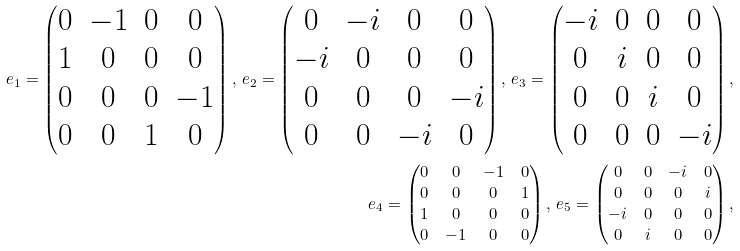<formula> <loc_0><loc_0><loc_500><loc_500>e _ { 1 } = \begin{pmatrix} 0 & - 1 & 0 & 0 \\ 1 & 0 & 0 & 0 \\ 0 & 0 & 0 & - 1 \\ 0 & 0 & 1 & 0 \end{pmatrix} , \, e _ { 2 } = \begin{pmatrix} 0 & - i & 0 & 0 \\ - i & 0 & 0 & 0 \\ 0 & 0 & 0 & - i \\ 0 & 0 & - i & 0 \end{pmatrix} , \, e _ { 3 } = \begin{pmatrix} - i & 0 & 0 & 0 \\ 0 & i & 0 & 0 \\ 0 & 0 & i & 0 \\ 0 & 0 & 0 & - i \end{pmatrix} , \\ e _ { 4 } = \begin{pmatrix} 0 & 0 & - 1 & 0 \\ 0 & 0 & 0 & 1 \\ 1 & 0 & 0 & 0 \\ 0 & - 1 & 0 & 0 \end{pmatrix} , \, e _ { 5 } = \begin{pmatrix} 0 & 0 & - i & 0 \\ 0 & 0 & 0 & i \\ - i & 0 & 0 & 0 \\ 0 & i & 0 & 0 \end{pmatrix} ,</formula> 